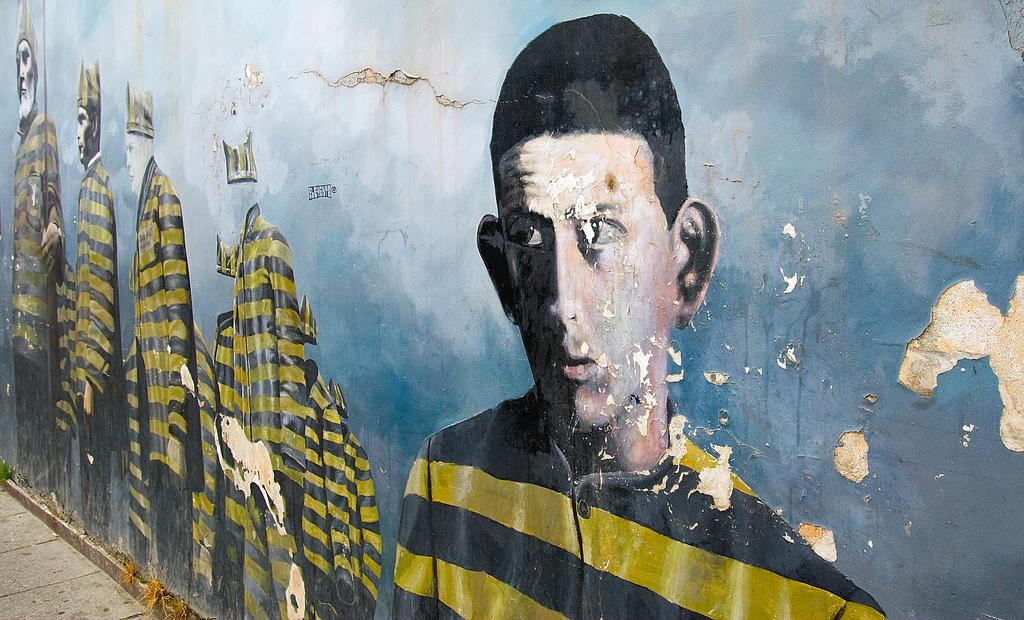What is present on the wall in the image? There are paintings of people on the wall in the image. What are the people in the paintings wearing? The people in the paintings are wearing yellow and gray dresses. What colors are used on the wall? The wall has a blue and white color scheme. What type of plastic material can be seen in the image? There is no plastic material present in the image. How does the ray of sunshine interact with the people in the paintings? There is no ray of sunshine present in the image; it only features paintings on a wall. 